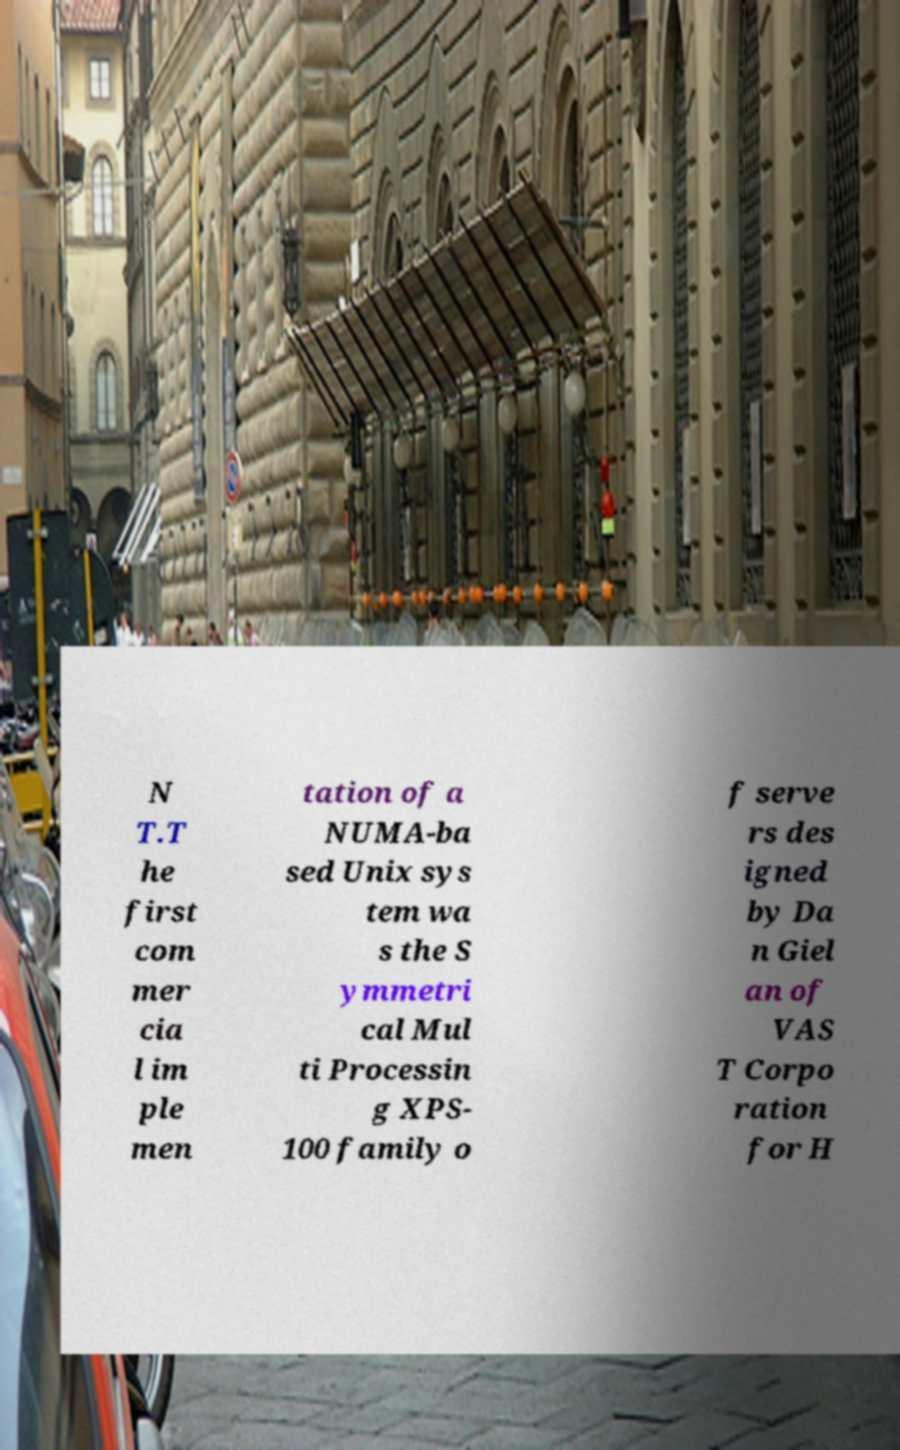What messages or text are displayed in this image? I need them in a readable, typed format. N T.T he first com mer cia l im ple men tation of a NUMA-ba sed Unix sys tem wa s the S ymmetri cal Mul ti Processin g XPS- 100 family o f serve rs des igned by Da n Giel an of VAS T Corpo ration for H 